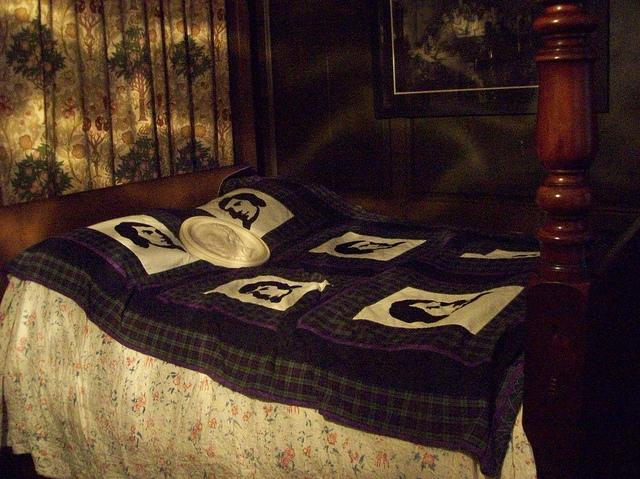What is on the bed?

Choices:
A) faces
B) green beans
C) rose petals
D) apples faces 